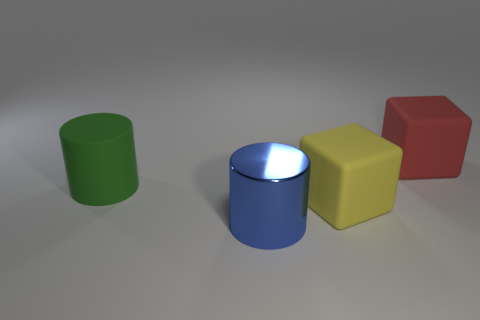How many big green objects are behind the big rubber object that is behind the large green thing?
Offer a terse response. 0. There is a large object that is both in front of the large green object and behind the big blue thing; what is its shape?
Provide a short and direct response. Cube. What material is the cube that is on the right side of the large matte thing that is in front of the big cylinder that is on the left side of the big blue metallic cylinder?
Provide a succinct answer. Rubber. What material is the large red thing?
Offer a very short reply. Rubber. Is the big yellow thing made of the same material as the big block behind the large yellow rubber thing?
Your answer should be very brief. Yes. There is a block that is behind the cylinder behind the blue thing; what is its color?
Your answer should be very brief. Red. How big is the object that is left of the yellow matte block and behind the shiny cylinder?
Keep it short and to the point. Large. There is a big yellow thing; does it have the same shape as the matte object that is on the left side of the large metallic thing?
Keep it short and to the point. No. What number of yellow matte blocks are behind the green cylinder?
Your answer should be very brief. 0. Is there any other thing that is made of the same material as the large red block?
Provide a succinct answer. Yes. 